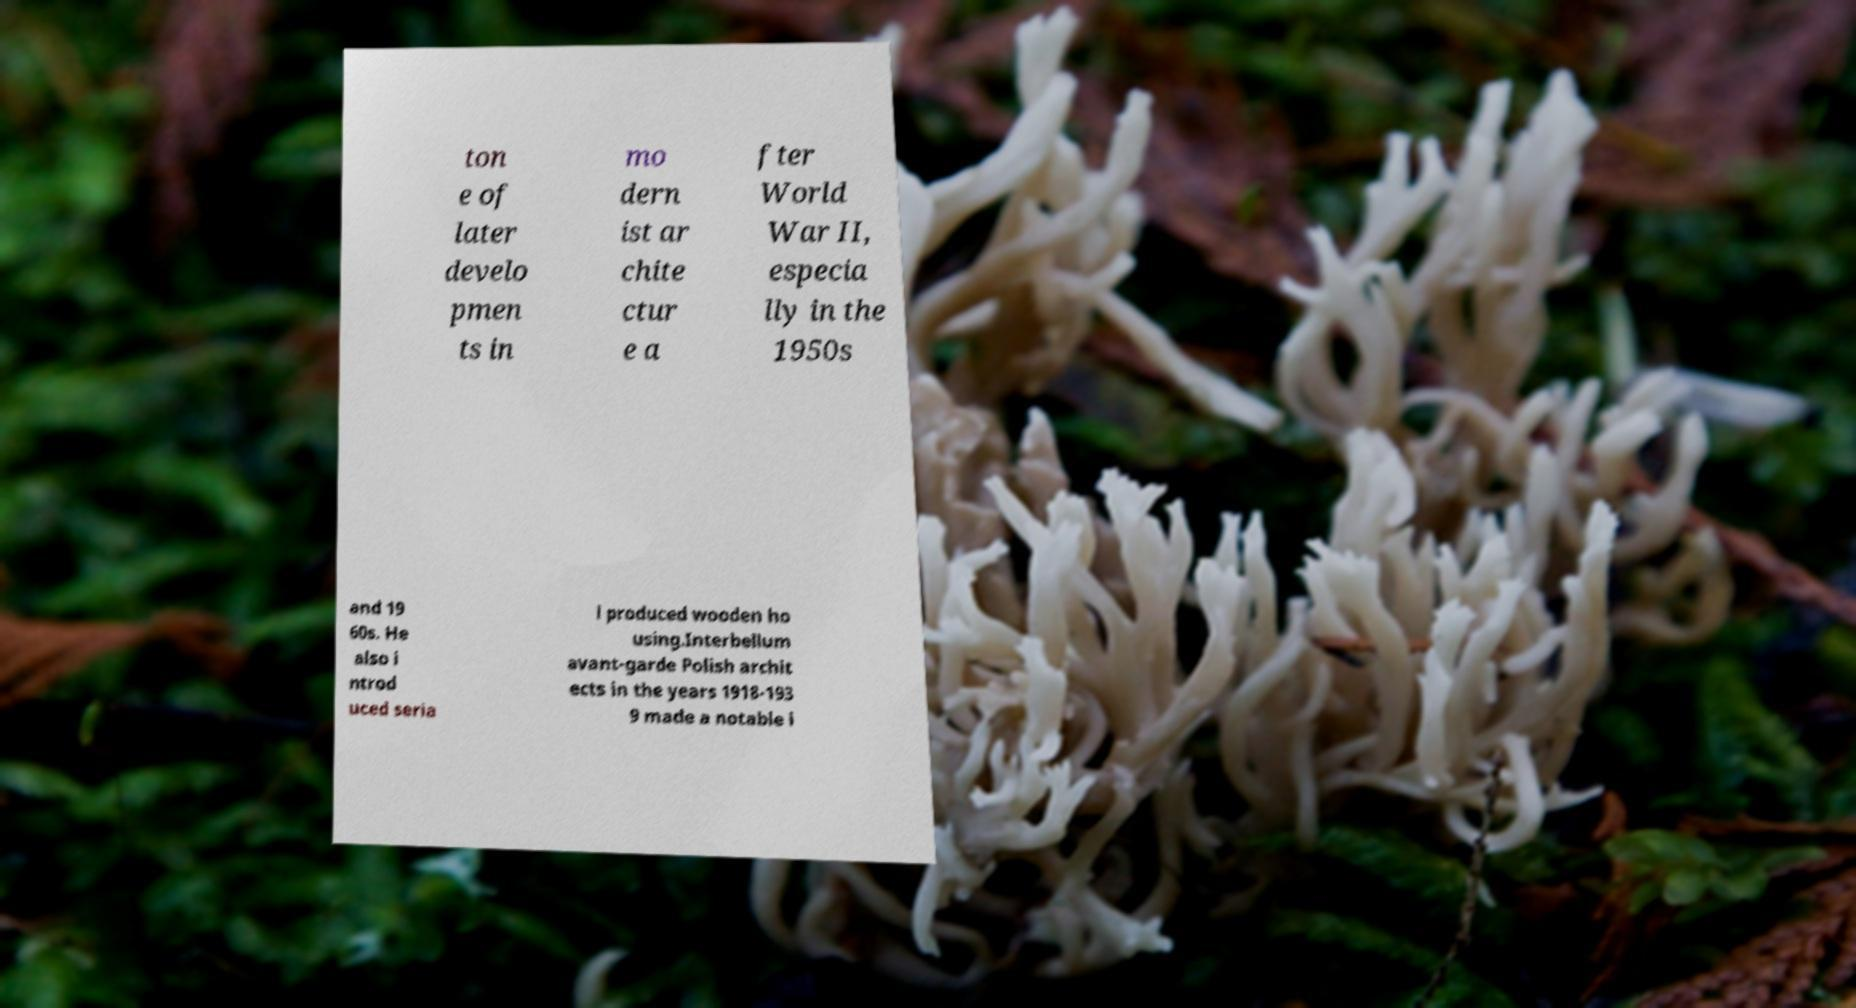I need the written content from this picture converted into text. Can you do that? ton e of later develo pmen ts in mo dern ist ar chite ctur e a fter World War II, especia lly in the 1950s and 19 60s. He also i ntrod uced seria l produced wooden ho using.Interbellum avant-garde Polish archit ects in the years 1918-193 9 made a notable i 